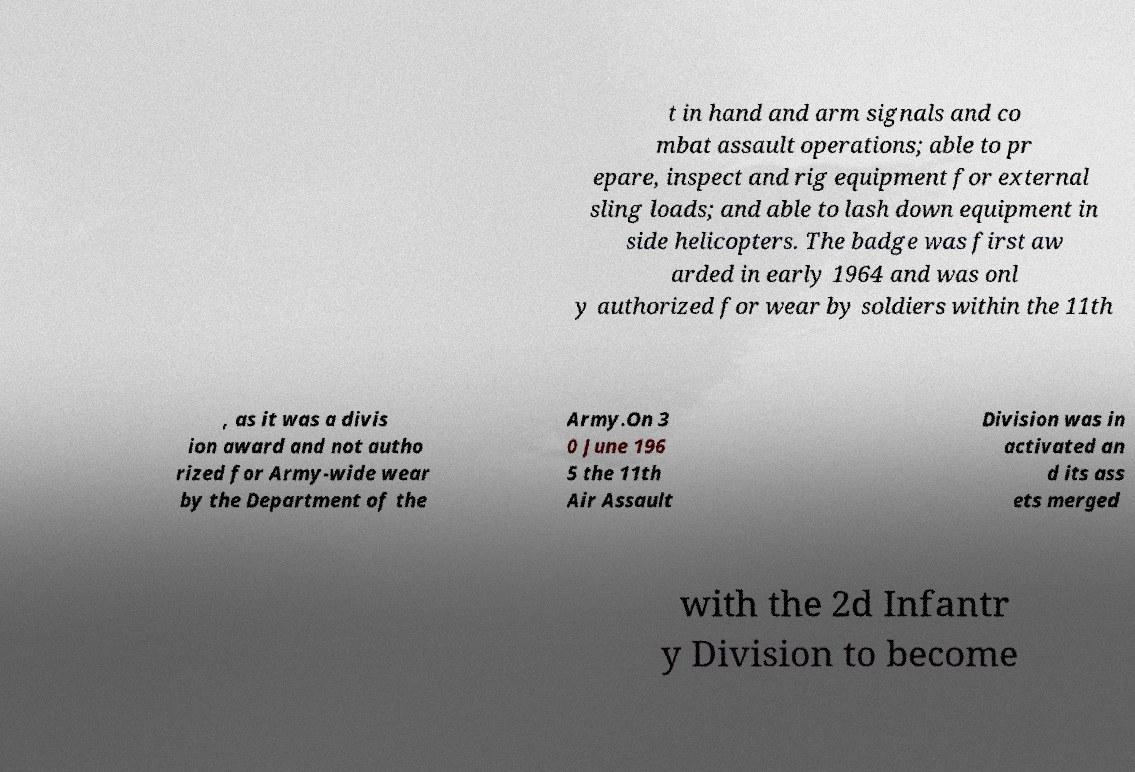What messages or text are displayed in this image? I need them in a readable, typed format. t in hand and arm signals and co mbat assault operations; able to pr epare, inspect and rig equipment for external sling loads; and able to lash down equipment in side helicopters. The badge was first aw arded in early 1964 and was onl y authorized for wear by soldiers within the 11th , as it was a divis ion award and not autho rized for Army-wide wear by the Department of the Army.On 3 0 June 196 5 the 11th Air Assault Division was in activated an d its ass ets merged with the 2d Infantr y Division to become 